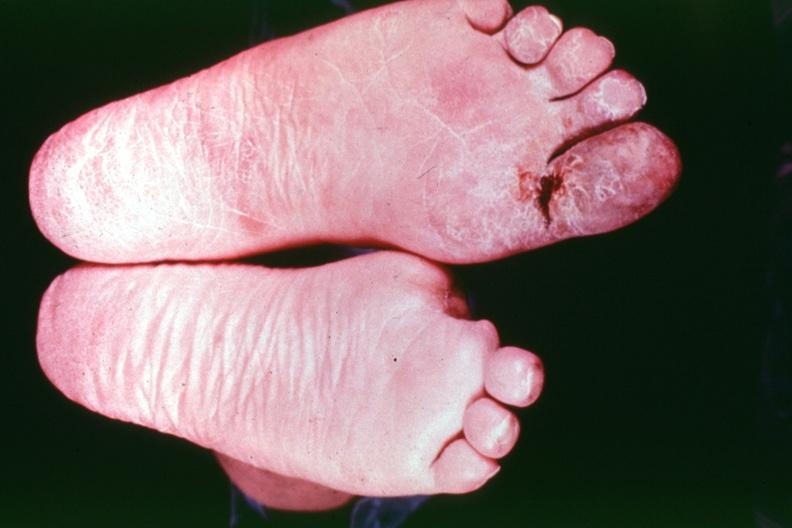what does this image show?
Answer the question using a single word or phrase. Buergers disease 